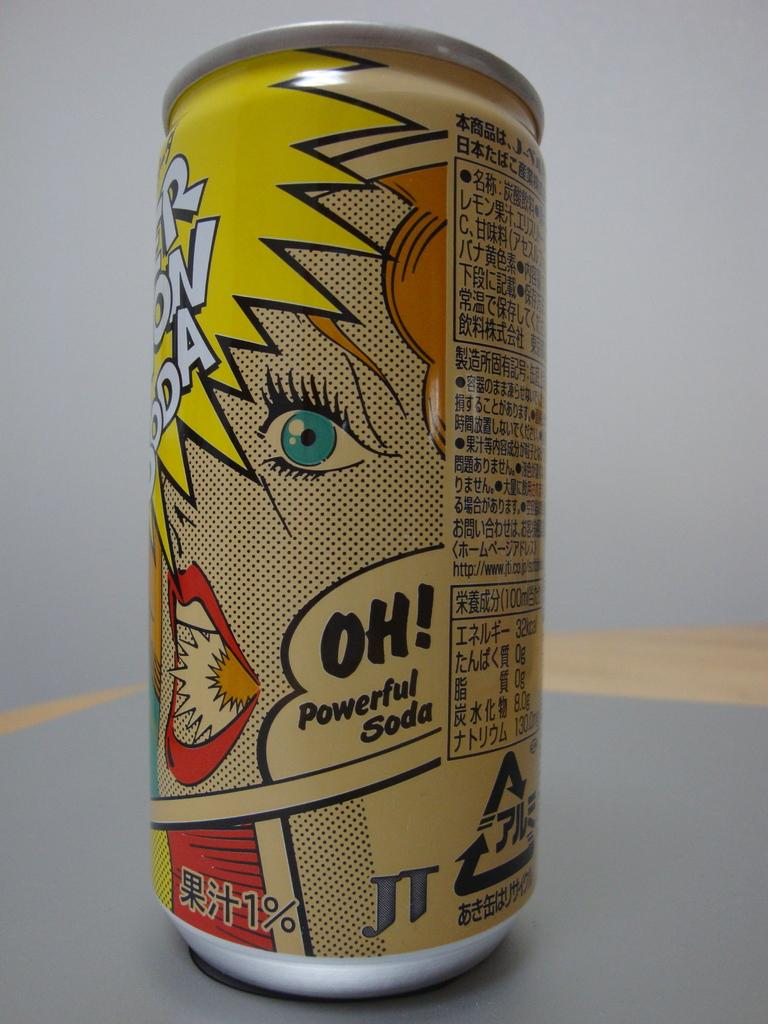<image>
Relay a brief, clear account of the picture shown. An energy drink says Oh Powerful Soda on the side. 